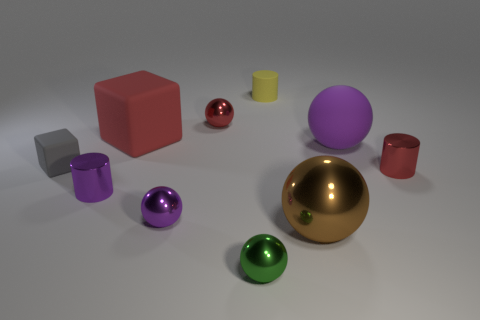What is the red thing on the left side of the tiny sphere that is behind the cube that is to the left of the big matte block made of?
Offer a very short reply. Rubber. Is the gray matte thing the same size as the red cube?
Give a very brief answer. No. What is the material of the big red object?
Offer a terse response. Rubber. There is a red thing that is behind the large red matte object; does it have the same shape as the large red rubber thing?
Offer a terse response. No. How many objects are either red rubber cubes or purple shiny balls?
Provide a short and direct response. 2. Does the large ball that is right of the brown shiny object have the same material as the tiny gray cube?
Offer a very short reply. Yes. The red matte cube is what size?
Give a very brief answer. Large. What number of balls are either tiny yellow matte objects or big brown things?
Offer a very short reply. 1. Is the number of small red metal cylinders that are left of the gray cube the same as the number of red balls that are on the left side of the green metal ball?
Provide a succinct answer. No. There is a matte thing that is the same shape as the green metallic thing; what is its size?
Your answer should be very brief. Large. 